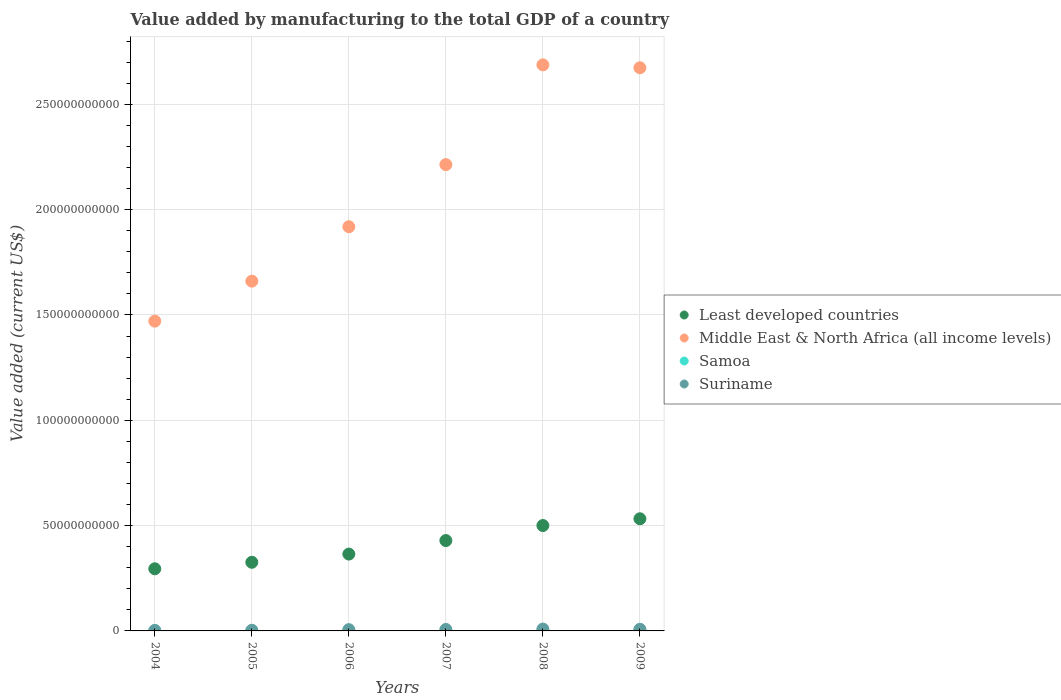How many different coloured dotlines are there?
Your answer should be compact. 4. Is the number of dotlines equal to the number of legend labels?
Offer a very short reply. Yes. What is the value added by manufacturing to the total GDP in Samoa in 2004?
Give a very brief answer. 8.77e+07. Across all years, what is the maximum value added by manufacturing to the total GDP in Samoa?
Ensure brevity in your answer.  1.09e+08. Across all years, what is the minimum value added by manufacturing to the total GDP in Samoa?
Make the answer very short. 7.09e+07. In which year was the value added by manufacturing to the total GDP in Least developed countries minimum?
Offer a very short reply. 2004. What is the total value added by manufacturing to the total GDP in Samoa in the graph?
Provide a short and direct response. 5.54e+08. What is the difference between the value added by manufacturing to the total GDP in Middle East & North Africa (all income levels) in 2004 and that in 2005?
Offer a terse response. -1.90e+1. What is the difference between the value added by manufacturing to the total GDP in Suriname in 2005 and the value added by manufacturing to the total GDP in Least developed countries in 2009?
Give a very brief answer. -5.29e+1. What is the average value added by manufacturing to the total GDP in Middle East & North Africa (all income levels) per year?
Give a very brief answer. 2.10e+11. In the year 2007, what is the difference between the value added by manufacturing to the total GDP in Suriname and value added by manufacturing to the total GDP in Least developed countries?
Provide a short and direct response. -4.22e+1. In how many years, is the value added by manufacturing to the total GDP in Suriname greater than 240000000000 US$?
Keep it short and to the point. 0. What is the ratio of the value added by manufacturing to the total GDP in Least developed countries in 2004 to that in 2006?
Your response must be concise. 0.81. What is the difference between the highest and the second highest value added by manufacturing to the total GDP in Middle East & North Africa (all income levels)?
Provide a short and direct response. 1.38e+09. What is the difference between the highest and the lowest value added by manufacturing to the total GDP in Least developed countries?
Provide a short and direct response. 2.37e+1. Does the value added by manufacturing to the total GDP in Suriname monotonically increase over the years?
Provide a succinct answer. No. Is the value added by manufacturing to the total GDP in Least developed countries strictly less than the value added by manufacturing to the total GDP in Samoa over the years?
Provide a succinct answer. No. How many dotlines are there?
Offer a terse response. 4. What is the difference between two consecutive major ticks on the Y-axis?
Your answer should be compact. 5.00e+1. Are the values on the major ticks of Y-axis written in scientific E-notation?
Provide a short and direct response. No. Does the graph contain any zero values?
Keep it short and to the point. No. Where does the legend appear in the graph?
Offer a terse response. Center right. How are the legend labels stacked?
Give a very brief answer. Vertical. What is the title of the graph?
Keep it short and to the point. Value added by manufacturing to the total GDP of a country. Does "Italy" appear as one of the legend labels in the graph?
Your answer should be compact. No. What is the label or title of the Y-axis?
Your answer should be very brief. Value added (current US$). What is the Value added (current US$) in Least developed countries in 2004?
Provide a short and direct response. 2.95e+1. What is the Value added (current US$) of Middle East & North Africa (all income levels) in 2004?
Your response must be concise. 1.47e+11. What is the Value added (current US$) in Samoa in 2004?
Provide a succinct answer. 8.77e+07. What is the Value added (current US$) of Suriname in 2004?
Provide a short and direct response. 2.27e+08. What is the Value added (current US$) in Least developed countries in 2005?
Your answer should be very brief. 3.26e+1. What is the Value added (current US$) of Middle East & North Africa (all income levels) in 2005?
Give a very brief answer. 1.66e+11. What is the Value added (current US$) in Samoa in 2005?
Your answer should be compact. 9.46e+07. What is the Value added (current US$) in Suriname in 2005?
Ensure brevity in your answer.  2.99e+08. What is the Value added (current US$) in Least developed countries in 2006?
Offer a very short reply. 3.65e+1. What is the Value added (current US$) of Middle East & North Africa (all income levels) in 2006?
Your answer should be compact. 1.92e+11. What is the Value added (current US$) of Samoa in 2006?
Ensure brevity in your answer.  8.67e+07. What is the Value added (current US$) of Suriname in 2006?
Offer a very short reply. 6.09e+08. What is the Value added (current US$) of Least developed countries in 2007?
Keep it short and to the point. 4.29e+1. What is the Value added (current US$) of Middle East & North Africa (all income levels) in 2007?
Provide a succinct answer. 2.21e+11. What is the Value added (current US$) of Samoa in 2007?
Make the answer very short. 1.09e+08. What is the Value added (current US$) of Suriname in 2007?
Offer a very short reply. 6.90e+08. What is the Value added (current US$) of Least developed countries in 2008?
Make the answer very short. 5.00e+1. What is the Value added (current US$) in Middle East & North Africa (all income levels) in 2008?
Your answer should be compact. 2.69e+11. What is the Value added (current US$) of Samoa in 2008?
Make the answer very short. 1.06e+08. What is the Value added (current US$) in Suriname in 2008?
Your response must be concise. 8.94e+08. What is the Value added (current US$) in Least developed countries in 2009?
Provide a succinct answer. 5.32e+1. What is the Value added (current US$) of Middle East & North Africa (all income levels) in 2009?
Keep it short and to the point. 2.67e+11. What is the Value added (current US$) of Samoa in 2009?
Give a very brief answer. 7.09e+07. What is the Value added (current US$) of Suriname in 2009?
Ensure brevity in your answer.  7.85e+08. Across all years, what is the maximum Value added (current US$) in Least developed countries?
Give a very brief answer. 5.32e+1. Across all years, what is the maximum Value added (current US$) of Middle East & North Africa (all income levels)?
Your answer should be very brief. 2.69e+11. Across all years, what is the maximum Value added (current US$) of Samoa?
Ensure brevity in your answer.  1.09e+08. Across all years, what is the maximum Value added (current US$) of Suriname?
Keep it short and to the point. 8.94e+08. Across all years, what is the minimum Value added (current US$) of Least developed countries?
Keep it short and to the point. 2.95e+1. Across all years, what is the minimum Value added (current US$) of Middle East & North Africa (all income levels)?
Keep it short and to the point. 1.47e+11. Across all years, what is the minimum Value added (current US$) in Samoa?
Your response must be concise. 7.09e+07. Across all years, what is the minimum Value added (current US$) of Suriname?
Your answer should be very brief. 2.27e+08. What is the total Value added (current US$) of Least developed countries in the graph?
Your answer should be compact. 2.45e+11. What is the total Value added (current US$) of Middle East & North Africa (all income levels) in the graph?
Offer a terse response. 1.26e+12. What is the total Value added (current US$) of Samoa in the graph?
Offer a terse response. 5.54e+08. What is the total Value added (current US$) in Suriname in the graph?
Provide a succinct answer. 3.51e+09. What is the difference between the Value added (current US$) of Least developed countries in 2004 and that in 2005?
Offer a terse response. -3.08e+09. What is the difference between the Value added (current US$) of Middle East & North Africa (all income levels) in 2004 and that in 2005?
Provide a short and direct response. -1.90e+1. What is the difference between the Value added (current US$) of Samoa in 2004 and that in 2005?
Your answer should be very brief. -6.88e+06. What is the difference between the Value added (current US$) in Suriname in 2004 and that in 2005?
Provide a short and direct response. -7.25e+07. What is the difference between the Value added (current US$) of Least developed countries in 2004 and that in 2006?
Keep it short and to the point. -6.98e+09. What is the difference between the Value added (current US$) in Middle East & North Africa (all income levels) in 2004 and that in 2006?
Your response must be concise. -4.48e+1. What is the difference between the Value added (current US$) of Samoa in 2004 and that in 2006?
Offer a terse response. 1.02e+06. What is the difference between the Value added (current US$) of Suriname in 2004 and that in 2006?
Provide a succinct answer. -3.82e+08. What is the difference between the Value added (current US$) of Least developed countries in 2004 and that in 2007?
Your answer should be compact. -1.34e+1. What is the difference between the Value added (current US$) in Middle East & North Africa (all income levels) in 2004 and that in 2007?
Your response must be concise. -7.43e+1. What is the difference between the Value added (current US$) of Samoa in 2004 and that in 2007?
Give a very brief answer. -2.12e+07. What is the difference between the Value added (current US$) in Suriname in 2004 and that in 2007?
Offer a terse response. -4.63e+08. What is the difference between the Value added (current US$) of Least developed countries in 2004 and that in 2008?
Your answer should be compact. -2.05e+1. What is the difference between the Value added (current US$) of Middle East & North Africa (all income levels) in 2004 and that in 2008?
Make the answer very short. -1.22e+11. What is the difference between the Value added (current US$) of Samoa in 2004 and that in 2008?
Make the answer very short. -1.80e+07. What is the difference between the Value added (current US$) in Suriname in 2004 and that in 2008?
Give a very brief answer. -6.67e+08. What is the difference between the Value added (current US$) in Least developed countries in 2004 and that in 2009?
Offer a very short reply. -2.37e+1. What is the difference between the Value added (current US$) of Middle East & North Africa (all income levels) in 2004 and that in 2009?
Make the answer very short. -1.20e+11. What is the difference between the Value added (current US$) of Samoa in 2004 and that in 2009?
Your response must be concise. 1.68e+07. What is the difference between the Value added (current US$) in Suriname in 2004 and that in 2009?
Provide a succinct answer. -5.58e+08. What is the difference between the Value added (current US$) in Least developed countries in 2005 and that in 2006?
Provide a succinct answer. -3.90e+09. What is the difference between the Value added (current US$) in Middle East & North Africa (all income levels) in 2005 and that in 2006?
Give a very brief answer. -2.58e+1. What is the difference between the Value added (current US$) in Samoa in 2005 and that in 2006?
Provide a succinct answer. 7.90e+06. What is the difference between the Value added (current US$) in Suriname in 2005 and that in 2006?
Provide a short and direct response. -3.10e+08. What is the difference between the Value added (current US$) in Least developed countries in 2005 and that in 2007?
Ensure brevity in your answer.  -1.03e+1. What is the difference between the Value added (current US$) in Middle East & North Africa (all income levels) in 2005 and that in 2007?
Give a very brief answer. -5.53e+1. What is the difference between the Value added (current US$) of Samoa in 2005 and that in 2007?
Ensure brevity in your answer.  -1.43e+07. What is the difference between the Value added (current US$) of Suriname in 2005 and that in 2007?
Ensure brevity in your answer.  -3.90e+08. What is the difference between the Value added (current US$) of Least developed countries in 2005 and that in 2008?
Ensure brevity in your answer.  -1.74e+1. What is the difference between the Value added (current US$) in Middle East & North Africa (all income levels) in 2005 and that in 2008?
Keep it short and to the point. -1.03e+11. What is the difference between the Value added (current US$) of Samoa in 2005 and that in 2008?
Your response must be concise. -1.11e+07. What is the difference between the Value added (current US$) in Suriname in 2005 and that in 2008?
Ensure brevity in your answer.  -5.95e+08. What is the difference between the Value added (current US$) in Least developed countries in 2005 and that in 2009?
Your answer should be very brief. -2.07e+1. What is the difference between the Value added (current US$) of Middle East & North Africa (all income levels) in 2005 and that in 2009?
Offer a terse response. -1.01e+11. What is the difference between the Value added (current US$) of Samoa in 2005 and that in 2009?
Your response must be concise. 2.37e+07. What is the difference between the Value added (current US$) in Suriname in 2005 and that in 2009?
Your answer should be very brief. -4.86e+08. What is the difference between the Value added (current US$) in Least developed countries in 2006 and that in 2007?
Provide a succinct answer. -6.42e+09. What is the difference between the Value added (current US$) in Middle East & North Africa (all income levels) in 2006 and that in 2007?
Keep it short and to the point. -2.95e+1. What is the difference between the Value added (current US$) of Samoa in 2006 and that in 2007?
Make the answer very short. -2.22e+07. What is the difference between the Value added (current US$) in Suriname in 2006 and that in 2007?
Your response must be concise. -8.02e+07. What is the difference between the Value added (current US$) of Least developed countries in 2006 and that in 2008?
Your response must be concise. -1.35e+1. What is the difference between the Value added (current US$) of Middle East & North Africa (all income levels) in 2006 and that in 2008?
Give a very brief answer. -7.68e+1. What is the difference between the Value added (current US$) in Samoa in 2006 and that in 2008?
Offer a very short reply. -1.90e+07. What is the difference between the Value added (current US$) in Suriname in 2006 and that in 2008?
Make the answer very short. -2.85e+08. What is the difference between the Value added (current US$) in Least developed countries in 2006 and that in 2009?
Offer a terse response. -1.68e+1. What is the difference between the Value added (current US$) in Middle East & North Africa (all income levels) in 2006 and that in 2009?
Offer a very short reply. -7.55e+1. What is the difference between the Value added (current US$) in Samoa in 2006 and that in 2009?
Your answer should be very brief. 1.58e+07. What is the difference between the Value added (current US$) in Suriname in 2006 and that in 2009?
Keep it short and to the point. -1.76e+08. What is the difference between the Value added (current US$) in Least developed countries in 2007 and that in 2008?
Your response must be concise. -7.13e+09. What is the difference between the Value added (current US$) of Middle East & North Africa (all income levels) in 2007 and that in 2008?
Keep it short and to the point. -4.74e+1. What is the difference between the Value added (current US$) of Samoa in 2007 and that in 2008?
Your answer should be very brief. 3.23e+06. What is the difference between the Value added (current US$) in Suriname in 2007 and that in 2008?
Your response must be concise. -2.05e+08. What is the difference between the Value added (current US$) in Least developed countries in 2007 and that in 2009?
Provide a succinct answer. -1.03e+1. What is the difference between the Value added (current US$) in Middle East & North Africa (all income levels) in 2007 and that in 2009?
Give a very brief answer. -4.60e+1. What is the difference between the Value added (current US$) of Samoa in 2007 and that in 2009?
Your response must be concise. 3.80e+07. What is the difference between the Value added (current US$) of Suriname in 2007 and that in 2009?
Provide a succinct answer. -9.58e+07. What is the difference between the Value added (current US$) in Least developed countries in 2008 and that in 2009?
Offer a terse response. -3.21e+09. What is the difference between the Value added (current US$) of Middle East & North Africa (all income levels) in 2008 and that in 2009?
Keep it short and to the point. 1.38e+09. What is the difference between the Value added (current US$) of Samoa in 2008 and that in 2009?
Provide a succinct answer. 3.48e+07. What is the difference between the Value added (current US$) in Suriname in 2008 and that in 2009?
Offer a terse response. 1.09e+08. What is the difference between the Value added (current US$) in Least developed countries in 2004 and the Value added (current US$) in Middle East & North Africa (all income levels) in 2005?
Provide a succinct answer. -1.37e+11. What is the difference between the Value added (current US$) of Least developed countries in 2004 and the Value added (current US$) of Samoa in 2005?
Give a very brief answer. 2.94e+1. What is the difference between the Value added (current US$) of Least developed countries in 2004 and the Value added (current US$) of Suriname in 2005?
Your answer should be very brief. 2.92e+1. What is the difference between the Value added (current US$) in Middle East & North Africa (all income levels) in 2004 and the Value added (current US$) in Samoa in 2005?
Your response must be concise. 1.47e+11. What is the difference between the Value added (current US$) of Middle East & North Africa (all income levels) in 2004 and the Value added (current US$) of Suriname in 2005?
Ensure brevity in your answer.  1.47e+11. What is the difference between the Value added (current US$) in Samoa in 2004 and the Value added (current US$) in Suriname in 2005?
Ensure brevity in your answer.  -2.12e+08. What is the difference between the Value added (current US$) in Least developed countries in 2004 and the Value added (current US$) in Middle East & North Africa (all income levels) in 2006?
Offer a very short reply. -1.62e+11. What is the difference between the Value added (current US$) of Least developed countries in 2004 and the Value added (current US$) of Samoa in 2006?
Offer a terse response. 2.94e+1. What is the difference between the Value added (current US$) in Least developed countries in 2004 and the Value added (current US$) in Suriname in 2006?
Offer a very short reply. 2.89e+1. What is the difference between the Value added (current US$) of Middle East & North Africa (all income levels) in 2004 and the Value added (current US$) of Samoa in 2006?
Make the answer very short. 1.47e+11. What is the difference between the Value added (current US$) in Middle East & North Africa (all income levels) in 2004 and the Value added (current US$) in Suriname in 2006?
Offer a terse response. 1.46e+11. What is the difference between the Value added (current US$) of Samoa in 2004 and the Value added (current US$) of Suriname in 2006?
Offer a very short reply. -5.22e+08. What is the difference between the Value added (current US$) of Least developed countries in 2004 and the Value added (current US$) of Middle East & North Africa (all income levels) in 2007?
Offer a terse response. -1.92e+11. What is the difference between the Value added (current US$) in Least developed countries in 2004 and the Value added (current US$) in Samoa in 2007?
Make the answer very short. 2.94e+1. What is the difference between the Value added (current US$) of Least developed countries in 2004 and the Value added (current US$) of Suriname in 2007?
Provide a short and direct response. 2.88e+1. What is the difference between the Value added (current US$) in Middle East & North Africa (all income levels) in 2004 and the Value added (current US$) in Samoa in 2007?
Keep it short and to the point. 1.47e+11. What is the difference between the Value added (current US$) in Middle East & North Africa (all income levels) in 2004 and the Value added (current US$) in Suriname in 2007?
Offer a terse response. 1.46e+11. What is the difference between the Value added (current US$) in Samoa in 2004 and the Value added (current US$) in Suriname in 2007?
Your answer should be compact. -6.02e+08. What is the difference between the Value added (current US$) of Least developed countries in 2004 and the Value added (current US$) of Middle East & North Africa (all income levels) in 2008?
Provide a succinct answer. -2.39e+11. What is the difference between the Value added (current US$) of Least developed countries in 2004 and the Value added (current US$) of Samoa in 2008?
Your answer should be compact. 2.94e+1. What is the difference between the Value added (current US$) of Least developed countries in 2004 and the Value added (current US$) of Suriname in 2008?
Provide a succinct answer. 2.86e+1. What is the difference between the Value added (current US$) of Middle East & North Africa (all income levels) in 2004 and the Value added (current US$) of Samoa in 2008?
Your answer should be compact. 1.47e+11. What is the difference between the Value added (current US$) in Middle East & North Africa (all income levels) in 2004 and the Value added (current US$) in Suriname in 2008?
Give a very brief answer. 1.46e+11. What is the difference between the Value added (current US$) of Samoa in 2004 and the Value added (current US$) of Suriname in 2008?
Ensure brevity in your answer.  -8.07e+08. What is the difference between the Value added (current US$) of Least developed countries in 2004 and the Value added (current US$) of Middle East & North Africa (all income levels) in 2009?
Your answer should be very brief. -2.38e+11. What is the difference between the Value added (current US$) of Least developed countries in 2004 and the Value added (current US$) of Samoa in 2009?
Your response must be concise. 2.94e+1. What is the difference between the Value added (current US$) of Least developed countries in 2004 and the Value added (current US$) of Suriname in 2009?
Your response must be concise. 2.87e+1. What is the difference between the Value added (current US$) in Middle East & North Africa (all income levels) in 2004 and the Value added (current US$) in Samoa in 2009?
Your response must be concise. 1.47e+11. What is the difference between the Value added (current US$) of Middle East & North Africa (all income levels) in 2004 and the Value added (current US$) of Suriname in 2009?
Keep it short and to the point. 1.46e+11. What is the difference between the Value added (current US$) in Samoa in 2004 and the Value added (current US$) in Suriname in 2009?
Provide a succinct answer. -6.98e+08. What is the difference between the Value added (current US$) in Least developed countries in 2005 and the Value added (current US$) in Middle East & North Africa (all income levels) in 2006?
Your answer should be compact. -1.59e+11. What is the difference between the Value added (current US$) in Least developed countries in 2005 and the Value added (current US$) in Samoa in 2006?
Offer a terse response. 3.25e+1. What is the difference between the Value added (current US$) in Least developed countries in 2005 and the Value added (current US$) in Suriname in 2006?
Provide a succinct answer. 3.20e+1. What is the difference between the Value added (current US$) of Middle East & North Africa (all income levels) in 2005 and the Value added (current US$) of Samoa in 2006?
Keep it short and to the point. 1.66e+11. What is the difference between the Value added (current US$) in Middle East & North Africa (all income levels) in 2005 and the Value added (current US$) in Suriname in 2006?
Provide a short and direct response. 1.65e+11. What is the difference between the Value added (current US$) of Samoa in 2005 and the Value added (current US$) of Suriname in 2006?
Your response must be concise. -5.15e+08. What is the difference between the Value added (current US$) in Least developed countries in 2005 and the Value added (current US$) in Middle East & North Africa (all income levels) in 2007?
Your answer should be very brief. -1.89e+11. What is the difference between the Value added (current US$) in Least developed countries in 2005 and the Value added (current US$) in Samoa in 2007?
Provide a succinct answer. 3.25e+1. What is the difference between the Value added (current US$) of Least developed countries in 2005 and the Value added (current US$) of Suriname in 2007?
Offer a terse response. 3.19e+1. What is the difference between the Value added (current US$) of Middle East & North Africa (all income levels) in 2005 and the Value added (current US$) of Samoa in 2007?
Provide a succinct answer. 1.66e+11. What is the difference between the Value added (current US$) of Middle East & North Africa (all income levels) in 2005 and the Value added (current US$) of Suriname in 2007?
Give a very brief answer. 1.65e+11. What is the difference between the Value added (current US$) of Samoa in 2005 and the Value added (current US$) of Suriname in 2007?
Make the answer very short. -5.95e+08. What is the difference between the Value added (current US$) in Least developed countries in 2005 and the Value added (current US$) in Middle East & North Africa (all income levels) in 2008?
Provide a succinct answer. -2.36e+11. What is the difference between the Value added (current US$) of Least developed countries in 2005 and the Value added (current US$) of Samoa in 2008?
Provide a succinct answer. 3.25e+1. What is the difference between the Value added (current US$) of Least developed countries in 2005 and the Value added (current US$) of Suriname in 2008?
Keep it short and to the point. 3.17e+1. What is the difference between the Value added (current US$) in Middle East & North Africa (all income levels) in 2005 and the Value added (current US$) in Samoa in 2008?
Offer a terse response. 1.66e+11. What is the difference between the Value added (current US$) in Middle East & North Africa (all income levels) in 2005 and the Value added (current US$) in Suriname in 2008?
Offer a very short reply. 1.65e+11. What is the difference between the Value added (current US$) of Samoa in 2005 and the Value added (current US$) of Suriname in 2008?
Keep it short and to the point. -8.00e+08. What is the difference between the Value added (current US$) of Least developed countries in 2005 and the Value added (current US$) of Middle East & North Africa (all income levels) in 2009?
Your answer should be compact. -2.35e+11. What is the difference between the Value added (current US$) in Least developed countries in 2005 and the Value added (current US$) in Samoa in 2009?
Your answer should be very brief. 3.25e+1. What is the difference between the Value added (current US$) in Least developed countries in 2005 and the Value added (current US$) in Suriname in 2009?
Provide a short and direct response. 3.18e+1. What is the difference between the Value added (current US$) of Middle East & North Africa (all income levels) in 2005 and the Value added (current US$) of Samoa in 2009?
Give a very brief answer. 1.66e+11. What is the difference between the Value added (current US$) of Middle East & North Africa (all income levels) in 2005 and the Value added (current US$) of Suriname in 2009?
Your response must be concise. 1.65e+11. What is the difference between the Value added (current US$) of Samoa in 2005 and the Value added (current US$) of Suriname in 2009?
Ensure brevity in your answer.  -6.91e+08. What is the difference between the Value added (current US$) of Least developed countries in 2006 and the Value added (current US$) of Middle East & North Africa (all income levels) in 2007?
Your response must be concise. -1.85e+11. What is the difference between the Value added (current US$) in Least developed countries in 2006 and the Value added (current US$) in Samoa in 2007?
Provide a succinct answer. 3.64e+1. What is the difference between the Value added (current US$) of Least developed countries in 2006 and the Value added (current US$) of Suriname in 2007?
Your answer should be very brief. 3.58e+1. What is the difference between the Value added (current US$) in Middle East & North Africa (all income levels) in 2006 and the Value added (current US$) in Samoa in 2007?
Provide a succinct answer. 1.92e+11. What is the difference between the Value added (current US$) of Middle East & North Africa (all income levels) in 2006 and the Value added (current US$) of Suriname in 2007?
Offer a terse response. 1.91e+11. What is the difference between the Value added (current US$) of Samoa in 2006 and the Value added (current US$) of Suriname in 2007?
Ensure brevity in your answer.  -6.03e+08. What is the difference between the Value added (current US$) in Least developed countries in 2006 and the Value added (current US$) in Middle East & North Africa (all income levels) in 2008?
Offer a terse response. -2.32e+11. What is the difference between the Value added (current US$) of Least developed countries in 2006 and the Value added (current US$) of Samoa in 2008?
Keep it short and to the point. 3.64e+1. What is the difference between the Value added (current US$) of Least developed countries in 2006 and the Value added (current US$) of Suriname in 2008?
Make the answer very short. 3.56e+1. What is the difference between the Value added (current US$) of Middle East & North Africa (all income levels) in 2006 and the Value added (current US$) of Samoa in 2008?
Provide a succinct answer. 1.92e+11. What is the difference between the Value added (current US$) of Middle East & North Africa (all income levels) in 2006 and the Value added (current US$) of Suriname in 2008?
Your answer should be very brief. 1.91e+11. What is the difference between the Value added (current US$) in Samoa in 2006 and the Value added (current US$) in Suriname in 2008?
Ensure brevity in your answer.  -8.08e+08. What is the difference between the Value added (current US$) in Least developed countries in 2006 and the Value added (current US$) in Middle East & North Africa (all income levels) in 2009?
Give a very brief answer. -2.31e+11. What is the difference between the Value added (current US$) of Least developed countries in 2006 and the Value added (current US$) of Samoa in 2009?
Your response must be concise. 3.64e+1. What is the difference between the Value added (current US$) in Least developed countries in 2006 and the Value added (current US$) in Suriname in 2009?
Your response must be concise. 3.57e+1. What is the difference between the Value added (current US$) in Middle East & North Africa (all income levels) in 2006 and the Value added (current US$) in Samoa in 2009?
Give a very brief answer. 1.92e+11. What is the difference between the Value added (current US$) of Middle East & North Africa (all income levels) in 2006 and the Value added (current US$) of Suriname in 2009?
Provide a succinct answer. 1.91e+11. What is the difference between the Value added (current US$) in Samoa in 2006 and the Value added (current US$) in Suriname in 2009?
Provide a short and direct response. -6.99e+08. What is the difference between the Value added (current US$) in Least developed countries in 2007 and the Value added (current US$) in Middle East & North Africa (all income levels) in 2008?
Provide a short and direct response. -2.26e+11. What is the difference between the Value added (current US$) of Least developed countries in 2007 and the Value added (current US$) of Samoa in 2008?
Your answer should be compact. 4.28e+1. What is the difference between the Value added (current US$) of Least developed countries in 2007 and the Value added (current US$) of Suriname in 2008?
Keep it short and to the point. 4.20e+1. What is the difference between the Value added (current US$) of Middle East & North Africa (all income levels) in 2007 and the Value added (current US$) of Samoa in 2008?
Your response must be concise. 2.21e+11. What is the difference between the Value added (current US$) of Middle East & North Africa (all income levels) in 2007 and the Value added (current US$) of Suriname in 2008?
Give a very brief answer. 2.20e+11. What is the difference between the Value added (current US$) in Samoa in 2007 and the Value added (current US$) in Suriname in 2008?
Provide a short and direct response. -7.85e+08. What is the difference between the Value added (current US$) in Least developed countries in 2007 and the Value added (current US$) in Middle East & North Africa (all income levels) in 2009?
Make the answer very short. -2.24e+11. What is the difference between the Value added (current US$) of Least developed countries in 2007 and the Value added (current US$) of Samoa in 2009?
Make the answer very short. 4.28e+1. What is the difference between the Value added (current US$) of Least developed countries in 2007 and the Value added (current US$) of Suriname in 2009?
Provide a short and direct response. 4.21e+1. What is the difference between the Value added (current US$) in Middle East & North Africa (all income levels) in 2007 and the Value added (current US$) in Samoa in 2009?
Your answer should be very brief. 2.21e+11. What is the difference between the Value added (current US$) in Middle East & North Africa (all income levels) in 2007 and the Value added (current US$) in Suriname in 2009?
Keep it short and to the point. 2.21e+11. What is the difference between the Value added (current US$) of Samoa in 2007 and the Value added (current US$) of Suriname in 2009?
Your response must be concise. -6.77e+08. What is the difference between the Value added (current US$) of Least developed countries in 2008 and the Value added (current US$) of Middle East & North Africa (all income levels) in 2009?
Ensure brevity in your answer.  -2.17e+11. What is the difference between the Value added (current US$) in Least developed countries in 2008 and the Value added (current US$) in Samoa in 2009?
Your answer should be very brief. 5.00e+1. What is the difference between the Value added (current US$) of Least developed countries in 2008 and the Value added (current US$) of Suriname in 2009?
Your answer should be very brief. 4.92e+1. What is the difference between the Value added (current US$) of Middle East & North Africa (all income levels) in 2008 and the Value added (current US$) of Samoa in 2009?
Provide a succinct answer. 2.69e+11. What is the difference between the Value added (current US$) of Middle East & North Africa (all income levels) in 2008 and the Value added (current US$) of Suriname in 2009?
Your response must be concise. 2.68e+11. What is the difference between the Value added (current US$) of Samoa in 2008 and the Value added (current US$) of Suriname in 2009?
Provide a short and direct response. -6.80e+08. What is the average Value added (current US$) in Least developed countries per year?
Keep it short and to the point. 4.08e+1. What is the average Value added (current US$) of Middle East & North Africa (all income levels) per year?
Keep it short and to the point. 2.10e+11. What is the average Value added (current US$) of Samoa per year?
Your response must be concise. 9.24e+07. What is the average Value added (current US$) of Suriname per year?
Provide a short and direct response. 5.84e+08. In the year 2004, what is the difference between the Value added (current US$) in Least developed countries and Value added (current US$) in Middle East & North Africa (all income levels)?
Give a very brief answer. -1.18e+11. In the year 2004, what is the difference between the Value added (current US$) of Least developed countries and Value added (current US$) of Samoa?
Ensure brevity in your answer.  2.94e+1. In the year 2004, what is the difference between the Value added (current US$) in Least developed countries and Value added (current US$) in Suriname?
Your answer should be very brief. 2.93e+1. In the year 2004, what is the difference between the Value added (current US$) in Middle East & North Africa (all income levels) and Value added (current US$) in Samoa?
Your answer should be compact. 1.47e+11. In the year 2004, what is the difference between the Value added (current US$) of Middle East & North Africa (all income levels) and Value added (current US$) of Suriname?
Offer a very short reply. 1.47e+11. In the year 2004, what is the difference between the Value added (current US$) in Samoa and Value added (current US$) in Suriname?
Your answer should be compact. -1.39e+08. In the year 2005, what is the difference between the Value added (current US$) in Least developed countries and Value added (current US$) in Middle East & North Africa (all income levels)?
Offer a very short reply. -1.33e+11. In the year 2005, what is the difference between the Value added (current US$) in Least developed countries and Value added (current US$) in Samoa?
Your answer should be compact. 3.25e+1. In the year 2005, what is the difference between the Value added (current US$) of Least developed countries and Value added (current US$) of Suriname?
Make the answer very short. 3.23e+1. In the year 2005, what is the difference between the Value added (current US$) of Middle East & North Africa (all income levels) and Value added (current US$) of Samoa?
Make the answer very short. 1.66e+11. In the year 2005, what is the difference between the Value added (current US$) in Middle East & North Africa (all income levels) and Value added (current US$) in Suriname?
Make the answer very short. 1.66e+11. In the year 2005, what is the difference between the Value added (current US$) of Samoa and Value added (current US$) of Suriname?
Your answer should be very brief. -2.05e+08. In the year 2006, what is the difference between the Value added (current US$) of Least developed countries and Value added (current US$) of Middle East & North Africa (all income levels)?
Your response must be concise. -1.55e+11. In the year 2006, what is the difference between the Value added (current US$) of Least developed countries and Value added (current US$) of Samoa?
Your response must be concise. 3.64e+1. In the year 2006, what is the difference between the Value added (current US$) of Least developed countries and Value added (current US$) of Suriname?
Provide a succinct answer. 3.59e+1. In the year 2006, what is the difference between the Value added (current US$) in Middle East & North Africa (all income levels) and Value added (current US$) in Samoa?
Keep it short and to the point. 1.92e+11. In the year 2006, what is the difference between the Value added (current US$) of Middle East & North Africa (all income levels) and Value added (current US$) of Suriname?
Give a very brief answer. 1.91e+11. In the year 2006, what is the difference between the Value added (current US$) in Samoa and Value added (current US$) in Suriname?
Offer a very short reply. -5.23e+08. In the year 2007, what is the difference between the Value added (current US$) in Least developed countries and Value added (current US$) in Middle East & North Africa (all income levels)?
Your answer should be compact. -1.78e+11. In the year 2007, what is the difference between the Value added (current US$) of Least developed countries and Value added (current US$) of Samoa?
Provide a short and direct response. 4.28e+1. In the year 2007, what is the difference between the Value added (current US$) of Least developed countries and Value added (current US$) of Suriname?
Provide a short and direct response. 4.22e+1. In the year 2007, what is the difference between the Value added (current US$) in Middle East & North Africa (all income levels) and Value added (current US$) in Samoa?
Your answer should be compact. 2.21e+11. In the year 2007, what is the difference between the Value added (current US$) of Middle East & North Africa (all income levels) and Value added (current US$) of Suriname?
Offer a terse response. 2.21e+11. In the year 2007, what is the difference between the Value added (current US$) of Samoa and Value added (current US$) of Suriname?
Your answer should be very brief. -5.81e+08. In the year 2008, what is the difference between the Value added (current US$) of Least developed countries and Value added (current US$) of Middle East & North Africa (all income levels)?
Provide a succinct answer. -2.19e+11. In the year 2008, what is the difference between the Value added (current US$) of Least developed countries and Value added (current US$) of Samoa?
Your answer should be compact. 4.99e+1. In the year 2008, what is the difference between the Value added (current US$) in Least developed countries and Value added (current US$) in Suriname?
Offer a terse response. 4.91e+1. In the year 2008, what is the difference between the Value added (current US$) of Middle East & North Africa (all income levels) and Value added (current US$) of Samoa?
Provide a succinct answer. 2.69e+11. In the year 2008, what is the difference between the Value added (current US$) in Middle East & North Africa (all income levels) and Value added (current US$) in Suriname?
Your answer should be very brief. 2.68e+11. In the year 2008, what is the difference between the Value added (current US$) of Samoa and Value added (current US$) of Suriname?
Offer a terse response. -7.89e+08. In the year 2009, what is the difference between the Value added (current US$) of Least developed countries and Value added (current US$) of Middle East & North Africa (all income levels)?
Ensure brevity in your answer.  -2.14e+11. In the year 2009, what is the difference between the Value added (current US$) of Least developed countries and Value added (current US$) of Samoa?
Make the answer very short. 5.32e+1. In the year 2009, what is the difference between the Value added (current US$) in Least developed countries and Value added (current US$) in Suriname?
Your response must be concise. 5.24e+1. In the year 2009, what is the difference between the Value added (current US$) of Middle East & North Africa (all income levels) and Value added (current US$) of Samoa?
Your response must be concise. 2.67e+11. In the year 2009, what is the difference between the Value added (current US$) of Middle East & North Africa (all income levels) and Value added (current US$) of Suriname?
Provide a succinct answer. 2.67e+11. In the year 2009, what is the difference between the Value added (current US$) in Samoa and Value added (current US$) in Suriname?
Offer a very short reply. -7.15e+08. What is the ratio of the Value added (current US$) of Least developed countries in 2004 to that in 2005?
Offer a terse response. 0.91. What is the ratio of the Value added (current US$) of Middle East & North Africa (all income levels) in 2004 to that in 2005?
Provide a short and direct response. 0.89. What is the ratio of the Value added (current US$) of Samoa in 2004 to that in 2005?
Your answer should be very brief. 0.93. What is the ratio of the Value added (current US$) in Suriname in 2004 to that in 2005?
Your answer should be very brief. 0.76. What is the ratio of the Value added (current US$) in Least developed countries in 2004 to that in 2006?
Give a very brief answer. 0.81. What is the ratio of the Value added (current US$) of Middle East & North Africa (all income levels) in 2004 to that in 2006?
Offer a terse response. 0.77. What is the ratio of the Value added (current US$) in Samoa in 2004 to that in 2006?
Give a very brief answer. 1.01. What is the ratio of the Value added (current US$) in Suriname in 2004 to that in 2006?
Offer a terse response. 0.37. What is the ratio of the Value added (current US$) of Least developed countries in 2004 to that in 2007?
Offer a very short reply. 0.69. What is the ratio of the Value added (current US$) of Middle East & North Africa (all income levels) in 2004 to that in 2007?
Keep it short and to the point. 0.66. What is the ratio of the Value added (current US$) of Samoa in 2004 to that in 2007?
Keep it short and to the point. 0.81. What is the ratio of the Value added (current US$) in Suriname in 2004 to that in 2007?
Your answer should be very brief. 0.33. What is the ratio of the Value added (current US$) in Least developed countries in 2004 to that in 2008?
Provide a succinct answer. 0.59. What is the ratio of the Value added (current US$) in Middle East & North Africa (all income levels) in 2004 to that in 2008?
Your answer should be compact. 0.55. What is the ratio of the Value added (current US$) in Samoa in 2004 to that in 2008?
Make the answer very short. 0.83. What is the ratio of the Value added (current US$) in Suriname in 2004 to that in 2008?
Keep it short and to the point. 0.25. What is the ratio of the Value added (current US$) of Least developed countries in 2004 to that in 2009?
Your response must be concise. 0.55. What is the ratio of the Value added (current US$) in Middle East & North Africa (all income levels) in 2004 to that in 2009?
Make the answer very short. 0.55. What is the ratio of the Value added (current US$) in Samoa in 2004 to that in 2009?
Your response must be concise. 1.24. What is the ratio of the Value added (current US$) of Suriname in 2004 to that in 2009?
Your answer should be very brief. 0.29. What is the ratio of the Value added (current US$) in Least developed countries in 2005 to that in 2006?
Ensure brevity in your answer.  0.89. What is the ratio of the Value added (current US$) in Middle East & North Africa (all income levels) in 2005 to that in 2006?
Make the answer very short. 0.87. What is the ratio of the Value added (current US$) of Samoa in 2005 to that in 2006?
Your answer should be compact. 1.09. What is the ratio of the Value added (current US$) in Suriname in 2005 to that in 2006?
Your answer should be compact. 0.49. What is the ratio of the Value added (current US$) in Least developed countries in 2005 to that in 2007?
Provide a succinct answer. 0.76. What is the ratio of the Value added (current US$) in Middle East & North Africa (all income levels) in 2005 to that in 2007?
Your answer should be very brief. 0.75. What is the ratio of the Value added (current US$) in Samoa in 2005 to that in 2007?
Give a very brief answer. 0.87. What is the ratio of the Value added (current US$) in Suriname in 2005 to that in 2007?
Your response must be concise. 0.43. What is the ratio of the Value added (current US$) in Least developed countries in 2005 to that in 2008?
Offer a very short reply. 0.65. What is the ratio of the Value added (current US$) of Middle East & North Africa (all income levels) in 2005 to that in 2008?
Keep it short and to the point. 0.62. What is the ratio of the Value added (current US$) of Samoa in 2005 to that in 2008?
Your response must be concise. 0.9. What is the ratio of the Value added (current US$) of Suriname in 2005 to that in 2008?
Ensure brevity in your answer.  0.33. What is the ratio of the Value added (current US$) of Least developed countries in 2005 to that in 2009?
Offer a terse response. 0.61. What is the ratio of the Value added (current US$) of Middle East & North Africa (all income levels) in 2005 to that in 2009?
Provide a short and direct response. 0.62. What is the ratio of the Value added (current US$) in Samoa in 2005 to that in 2009?
Provide a succinct answer. 1.33. What is the ratio of the Value added (current US$) of Suriname in 2005 to that in 2009?
Keep it short and to the point. 0.38. What is the ratio of the Value added (current US$) of Least developed countries in 2006 to that in 2007?
Give a very brief answer. 0.85. What is the ratio of the Value added (current US$) of Middle East & North Africa (all income levels) in 2006 to that in 2007?
Your answer should be very brief. 0.87. What is the ratio of the Value added (current US$) in Samoa in 2006 to that in 2007?
Your answer should be very brief. 0.8. What is the ratio of the Value added (current US$) in Suriname in 2006 to that in 2007?
Offer a very short reply. 0.88. What is the ratio of the Value added (current US$) of Least developed countries in 2006 to that in 2008?
Provide a succinct answer. 0.73. What is the ratio of the Value added (current US$) in Middle East & North Africa (all income levels) in 2006 to that in 2008?
Your response must be concise. 0.71. What is the ratio of the Value added (current US$) of Samoa in 2006 to that in 2008?
Your answer should be very brief. 0.82. What is the ratio of the Value added (current US$) of Suriname in 2006 to that in 2008?
Provide a succinct answer. 0.68. What is the ratio of the Value added (current US$) in Least developed countries in 2006 to that in 2009?
Your answer should be compact. 0.69. What is the ratio of the Value added (current US$) in Middle East & North Africa (all income levels) in 2006 to that in 2009?
Provide a short and direct response. 0.72. What is the ratio of the Value added (current US$) in Samoa in 2006 to that in 2009?
Make the answer very short. 1.22. What is the ratio of the Value added (current US$) in Suriname in 2006 to that in 2009?
Your answer should be compact. 0.78. What is the ratio of the Value added (current US$) in Least developed countries in 2007 to that in 2008?
Give a very brief answer. 0.86. What is the ratio of the Value added (current US$) of Middle East & North Africa (all income levels) in 2007 to that in 2008?
Keep it short and to the point. 0.82. What is the ratio of the Value added (current US$) of Samoa in 2007 to that in 2008?
Make the answer very short. 1.03. What is the ratio of the Value added (current US$) of Suriname in 2007 to that in 2008?
Provide a short and direct response. 0.77. What is the ratio of the Value added (current US$) of Least developed countries in 2007 to that in 2009?
Your response must be concise. 0.81. What is the ratio of the Value added (current US$) in Middle East & North Africa (all income levels) in 2007 to that in 2009?
Your response must be concise. 0.83. What is the ratio of the Value added (current US$) in Samoa in 2007 to that in 2009?
Your answer should be very brief. 1.54. What is the ratio of the Value added (current US$) in Suriname in 2007 to that in 2009?
Your answer should be very brief. 0.88. What is the ratio of the Value added (current US$) in Least developed countries in 2008 to that in 2009?
Your answer should be very brief. 0.94. What is the ratio of the Value added (current US$) of Samoa in 2008 to that in 2009?
Provide a succinct answer. 1.49. What is the ratio of the Value added (current US$) in Suriname in 2008 to that in 2009?
Make the answer very short. 1.14. What is the difference between the highest and the second highest Value added (current US$) in Least developed countries?
Give a very brief answer. 3.21e+09. What is the difference between the highest and the second highest Value added (current US$) of Middle East & North Africa (all income levels)?
Ensure brevity in your answer.  1.38e+09. What is the difference between the highest and the second highest Value added (current US$) of Samoa?
Ensure brevity in your answer.  3.23e+06. What is the difference between the highest and the second highest Value added (current US$) of Suriname?
Provide a succinct answer. 1.09e+08. What is the difference between the highest and the lowest Value added (current US$) of Least developed countries?
Provide a succinct answer. 2.37e+1. What is the difference between the highest and the lowest Value added (current US$) of Middle East & North Africa (all income levels)?
Offer a terse response. 1.22e+11. What is the difference between the highest and the lowest Value added (current US$) of Samoa?
Give a very brief answer. 3.80e+07. What is the difference between the highest and the lowest Value added (current US$) in Suriname?
Ensure brevity in your answer.  6.67e+08. 